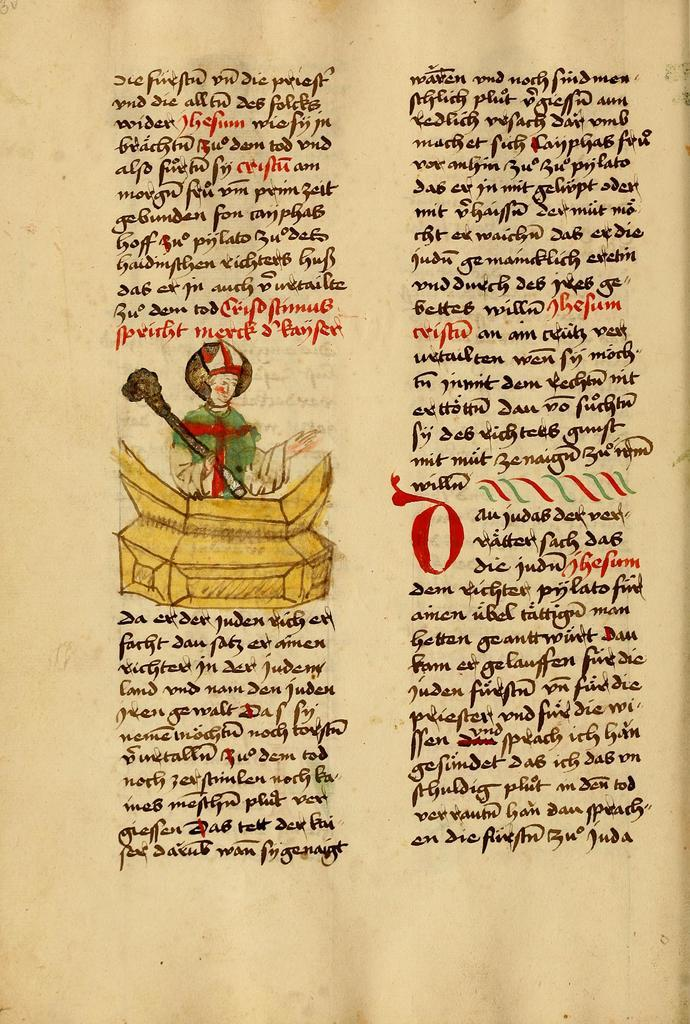What is present in the image? There is a paper in the image. What can be found on the paper? The paper contains text. Is there any visual element on the paper? Yes, there is an image of a person holding an object on the paper. What type of trail can be seen behind the person in the image? There is no trail visible in the image; it only contains an image of a person holding an object. What color are the eyes of the person in the image? The image does not show the person's eyes, so it is not possible to determine their color. 